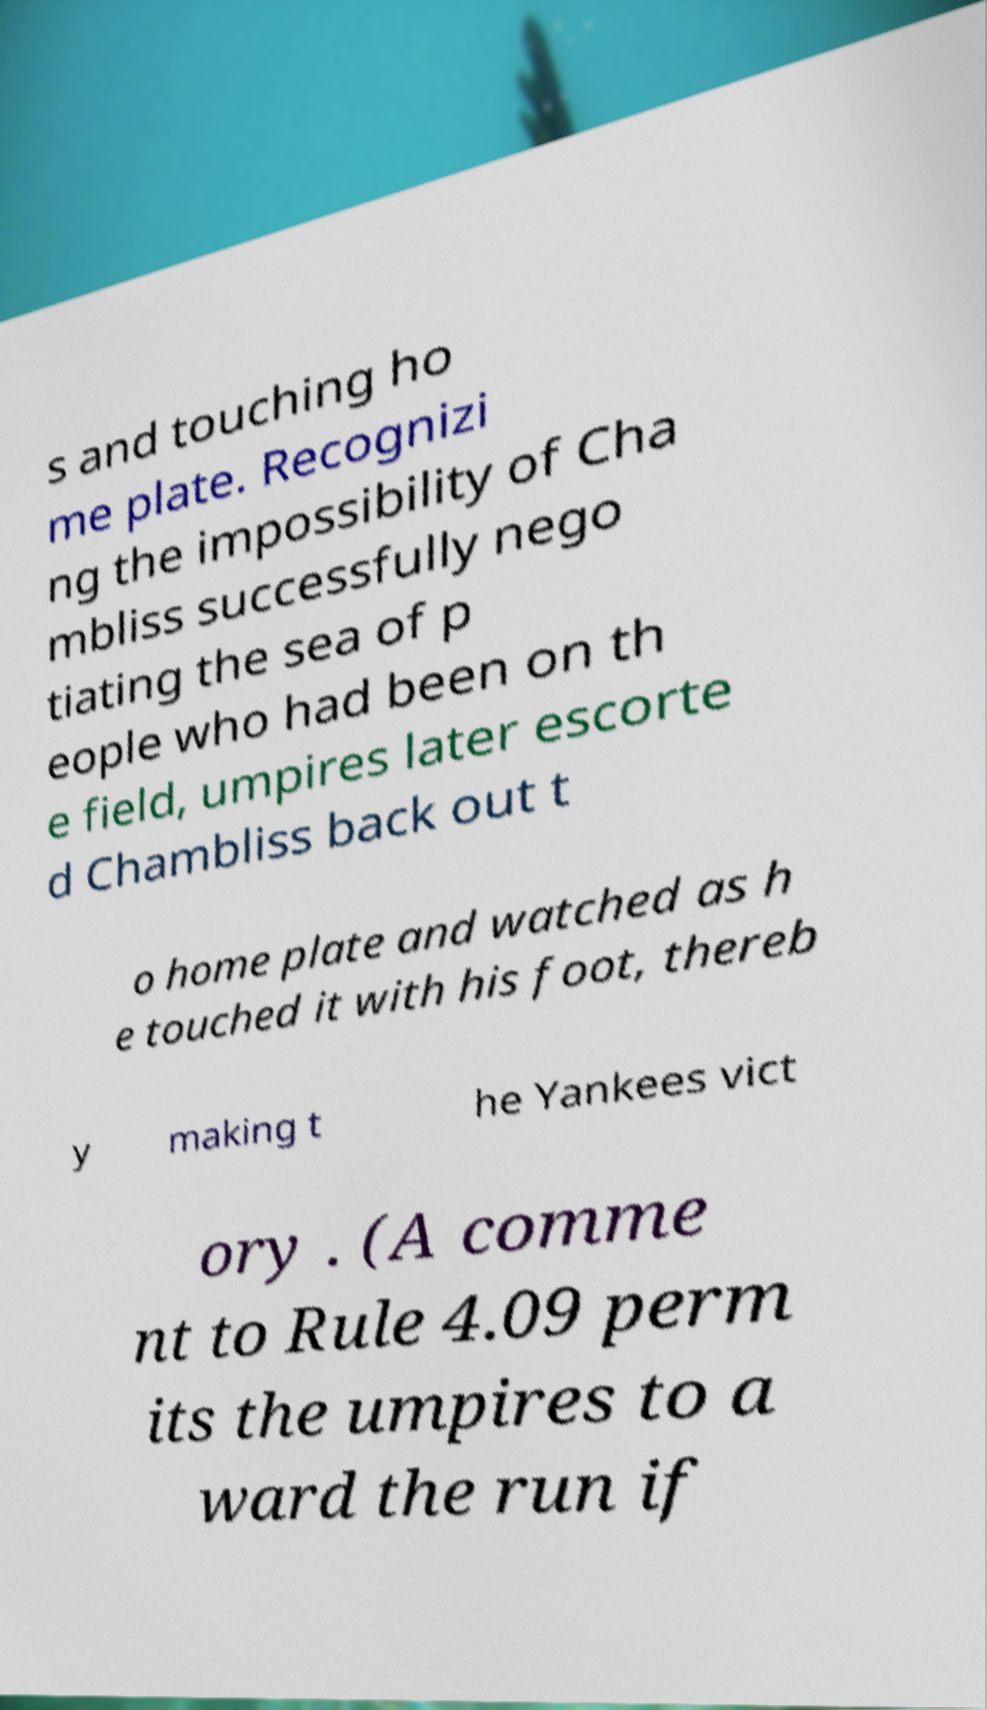There's text embedded in this image that I need extracted. Can you transcribe it verbatim? s and touching ho me plate. Recognizi ng the impossibility of Cha mbliss successfully nego tiating the sea of p eople who had been on th e field, umpires later escorte d Chambliss back out t o home plate and watched as h e touched it with his foot, thereb y making t he Yankees vict ory . (A comme nt to Rule 4.09 perm its the umpires to a ward the run if 